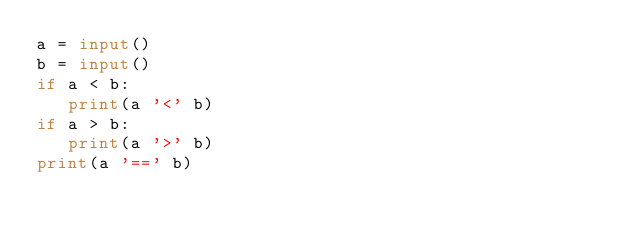<code> <loc_0><loc_0><loc_500><loc_500><_Python_>a = input()
b = input()
if a < b:
   print(a '<' b)
if a > b:
   print(a '>' b)
print(a '==' b)</code> 